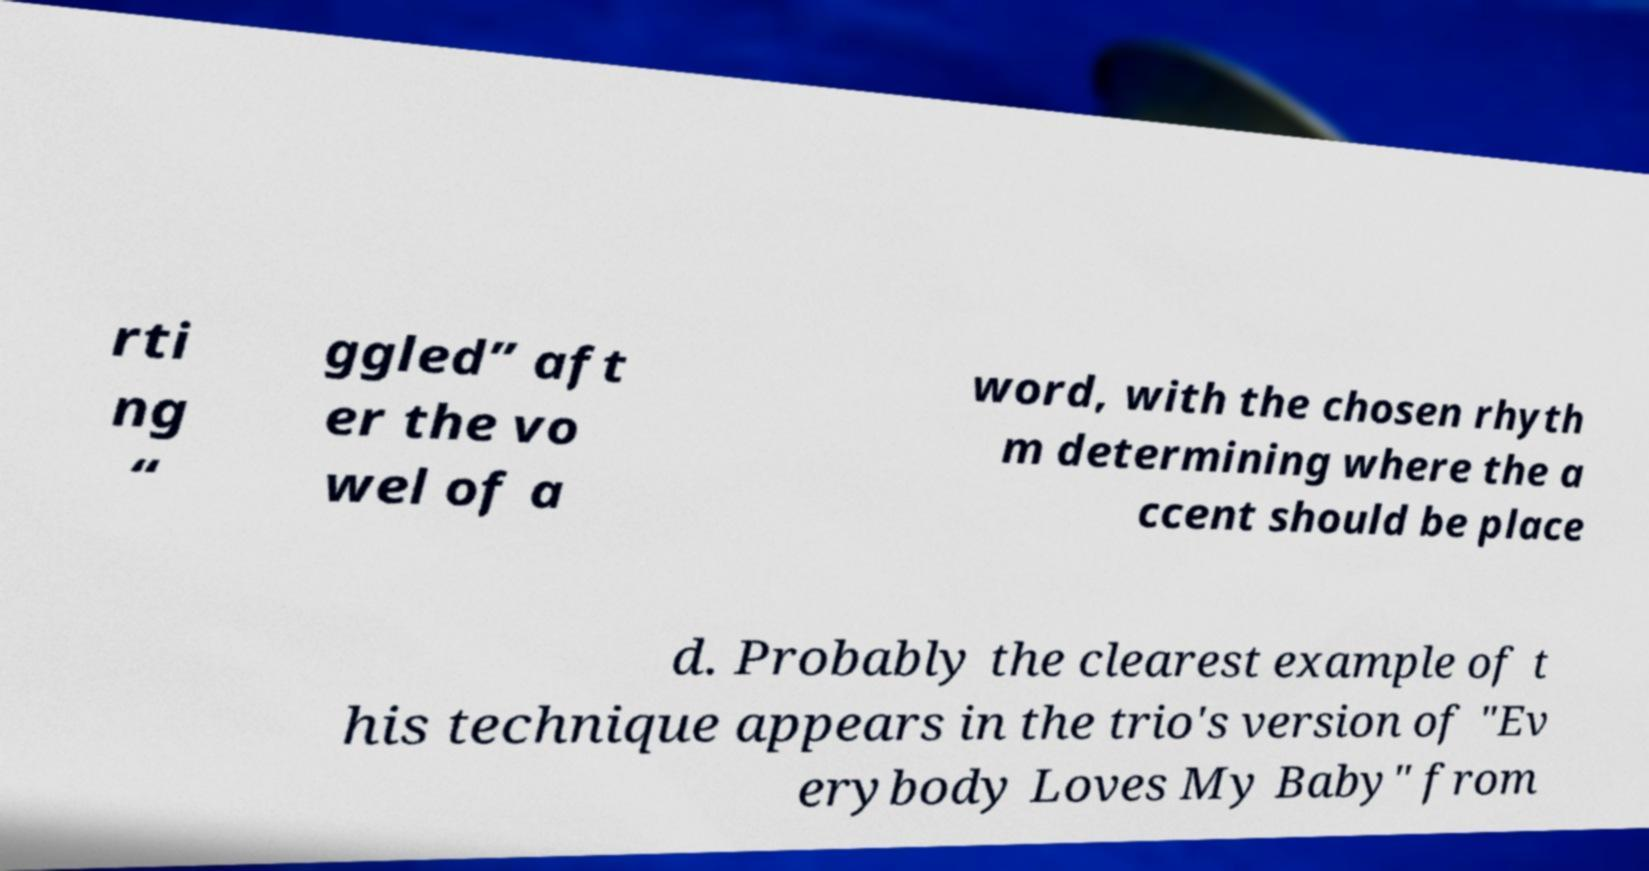Can you read and provide the text displayed in the image?This photo seems to have some interesting text. Can you extract and type it out for me? rti ng “ ggled” aft er the vo wel of a word, with the chosen rhyth m determining where the a ccent should be place d. Probably the clearest example of t his technique appears in the trio's version of "Ev erybody Loves My Baby" from 